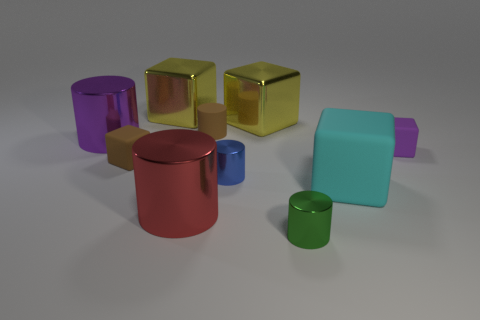Subtract all brown cubes. How many cubes are left? 4 Subtract all green spheres. How many yellow cubes are left? 2 Subtract 3 cubes. How many cubes are left? 2 Subtract all brown blocks. How many blocks are left? 4 Subtract all red cylinders. Subtract all cyan spheres. How many cylinders are left? 4 Subtract all large purple spheres. Subtract all large cyan rubber cubes. How many objects are left? 9 Add 5 matte blocks. How many matte blocks are left? 8 Add 9 tiny purple blocks. How many tiny purple blocks exist? 10 Subtract 1 brown blocks. How many objects are left? 9 